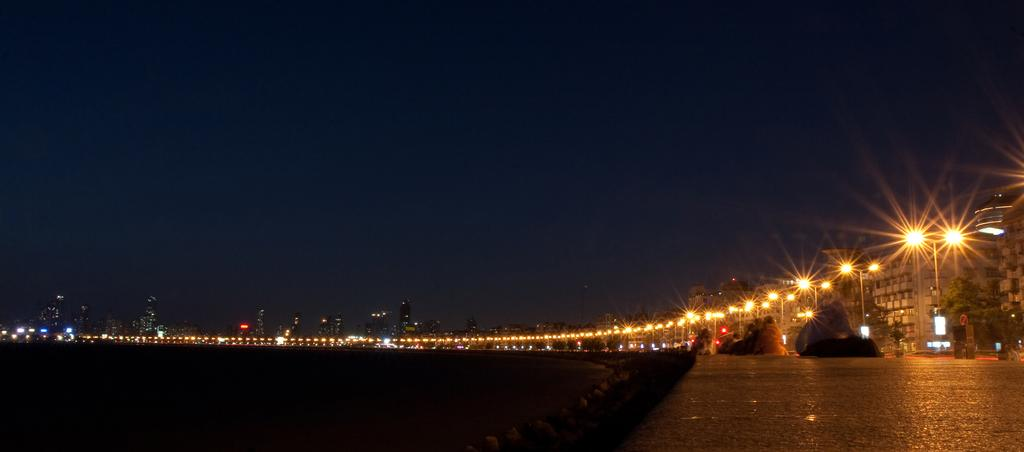What type of structures can be seen in the image? There are buildings, skyscrapers, and street poles in the image. What are the persons in the image doing? The persons in the image are sitting on the road. What type of objects can be seen on the ground in the image? There are stones in the image. What type of lighting is present in the image? There are street lights in the image. What type of vegetation is present in the image? There are trees in the image. What part of the natural environment is visible in the image? The sky is visible in the image. What type of learning activity is taking place in the image? There is no learning activity depicted in the image; it shows persons sitting on the road and various structures and objects. How does the playground look like in the image? There is no playground present in the image. 